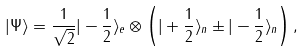Convert formula to latex. <formula><loc_0><loc_0><loc_500><loc_500>| \Psi \rangle = \frac { 1 } { \sqrt { 2 } } | - \frac { 1 } { 2 } \rangle _ { e } \otimes \left ( | + \frac { 1 } { 2 } \rangle _ { n } \pm | - \frac { 1 } { 2 } \rangle _ { n } \right ) ,</formula> 